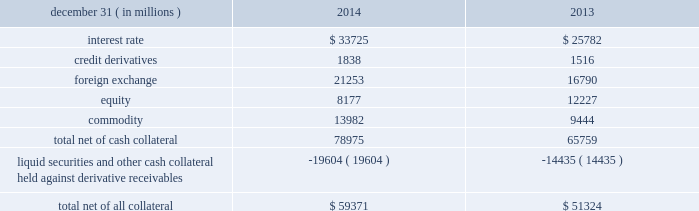Jpmorgan chase & co./2014 annual report 125 lending-related commitments the firm uses lending-related financial instruments , such as commitments ( including revolving credit facilities ) and guarantees , to meet the financing needs of its customers .
The contractual amounts of these financial instruments represent the maximum possible credit risk should the counterparties draw down on these commitments or the firm fulfills its obligations under these guarantees , and the counterparties subsequently fail to perform according to the terms of these contracts .
In the firm 2019s view , the total contractual amount of these wholesale lending-related commitments is not representative of the firm 2019s actual future credit exposure or funding requirements .
In determining the amount of credit risk exposure the firm has to wholesale lending-related commitments , which is used as the basis for allocating credit risk capital to these commitments , the firm has established a 201cloan-equivalent 201d amount for each commitment ; this amount represents the portion of the unused commitment or other contingent exposure that is expected , based on average portfolio historical experience , to become drawn upon in an event of a default by an obligor .
The loan-equivalent amount of the firm 2019s lending- related commitments was $ 229.6 billion and $ 218.9 billion as of december 31 , 2014 and 2013 , respectively .
Clearing services the firm provides clearing services for clients entering into securities and derivative transactions .
Through the provision of these services the firm is exposed to the risk of non-performance by its clients and may be required to share in losses incurred by central counterparties ( 201cccps 201d ) .
Where possible , the firm seeks to mitigate its credit risk to its clients through the collection of adequate margin at inception and throughout the life of the transactions and can also cease provision of clearing services if clients do not adhere to their obligations under the clearing agreement .
For further discussion of clearing services , see note 29 .
Derivative contracts in the normal course of business , the firm uses derivative instruments predominantly for market-making activities .
Derivatives enable customers to manage exposures to fluctuations in interest rates , currencies and other markets .
The firm also uses derivative instruments to manage its own credit exposure .
The nature of the counterparty and the settlement mechanism of the derivative affect the credit risk to which the firm is exposed .
For otc derivatives the firm is exposed to the credit risk of the derivative counterparty .
For exchange-traded derivatives ( 201cetd 201d ) such as futures and options , and 201ccleared 201d over-the-counter ( 201cotc-cleared 201d ) derivatives , the firm is generally exposed to the credit risk of the relevant ccp .
Where possible , the firm seeks to mitigate its credit risk exposures arising from derivative transactions through the use of legally enforceable master netting arrangements and collateral agreements .
For further discussion of derivative contracts , counterparties and settlement types , see note 6 .
The table summarizes the net derivative receivables for the periods presented .
Derivative receivables .
Derivative receivables reported on the consolidated balance sheets were $ 79.0 billion and $ 65.8 billion at december 31 , 2014 and 2013 , respectively .
These amounts represent the fair value of the derivative contracts , after giving effect to legally enforceable master netting agreements and cash collateral held by the firm .
However , in management 2019s view , the appropriate measure of current credit risk should also take into consideration additional liquid securities ( primarily u.s .
Government and agency securities and other g7 government bonds ) and other cash collateral held by the firm aggregating $ 19.6 billion and $ 14.4 billion at december 31 , 2014 and 2013 , respectively , that may be used as security when the fair value of the client 2019s exposure is in the firm 2019s favor .
In addition to the collateral described in the preceding paragraph , the firm also holds additional collateral ( primarily : cash ; g7 government securities ; other liquid government-agency and guaranteed securities ; and corporate debt and equity securities ) delivered by clients at the initiation of transactions , as well as collateral related to contracts that have a non-daily call frequency and collateral that the firm has agreed to return but has not yet settled as of the reporting date .
Although this collateral does not reduce the balances and is not included in the table above , it is available as security against potential exposure that could arise should the fair value of the client 2019s derivative transactions move in the firm 2019s favor .
As of december 31 , 2014 and 2013 , the firm held $ 48.6 billion and $ 50.8 billion , respectively , of this additional collateral .
The prior period amount has been revised to conform with the current period presentation .
The derivative receivables fair value , net of all collateral , also does not include other credit enhancements , such as letters of credit .
For additional information on the firm 2019s use of collateral agreements , see note 6. .
Based on the summary of the net derivative receivables what was the percent of of the foreign exchange? 
Computations: (21253 / 59371)
Answer: 0.35797. 